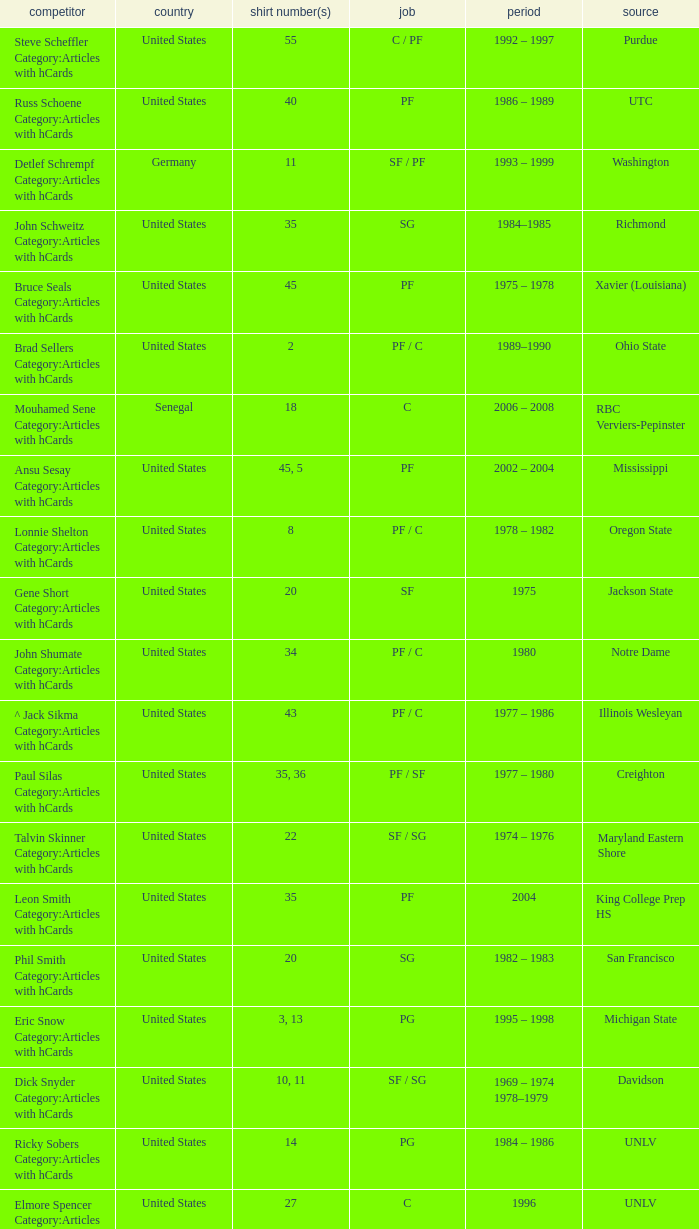Who wears the jersey number 20 and has the position of SG? Phil Smith Category:Articles with hCards, Jon Sundvold Category:Articles with hCards. 